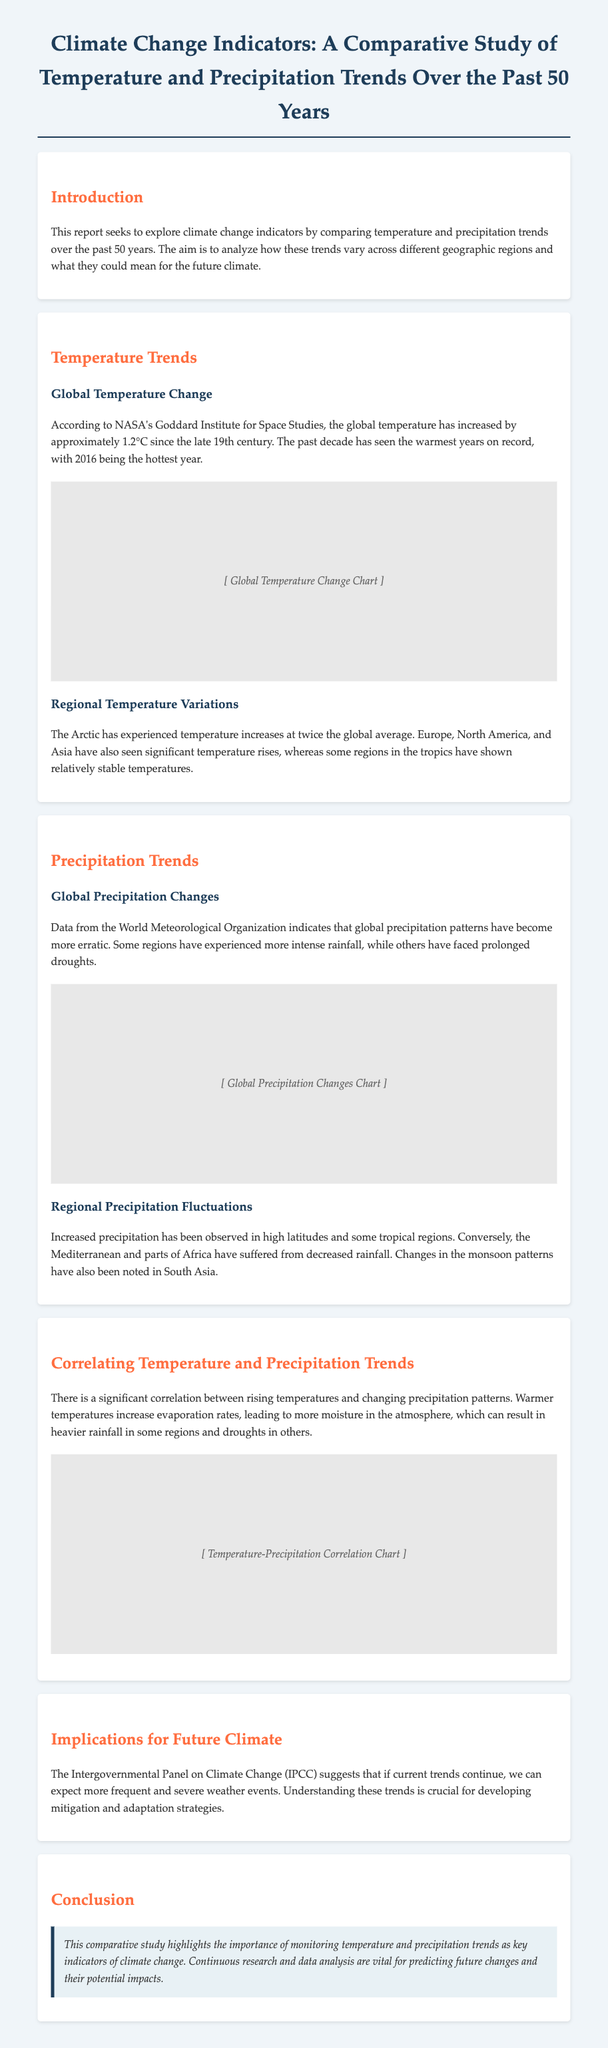What is the global temperature increase since the late 19th century? The report states that the global temperature has increased by approximately 1.2°C since the late 19th century.
Answer: 1.2°C Which year recorded the warmest temperature on record? According to the document, 2016 is noted as the hottest year on record.
Answer: 2016 What has happened to precipitation patterns globally? The document indicates that global precipitation patterns have become more erratic.
Answer: Erratic What region has experienced temperature changes at twice the global average? The report mentions that the Arctic has experienced temperature increases at twice the global average.
Answer: Arctic Which regions have seen increased rainfall? The report notes that increased precipitation has been observed in high latitudes and some tropical regions.
Answer: High latitudes and tropical regions How does warmer temperature influence precipitation? The document explains that warmer temperatures increase evaporation rates, leading to more moisture in the atmosphere.
Answer: More moisture What does the IPCC suggest about future weather events? The document indicates that the IPCC suggests if current trends continue, we can expect more frequent and severe weather events.
Answer: More frequent and severe What is the primary focus of this comparative study? The study primarily focuses on monitoring temperature and precipitation trends as key indicators of climate change.
Answer: Key indicators of climate change What type of trends does the report analyze? The report analyzes temperature and precipitation trends over the past 50 years.
Answer: Temperature and precipitation trends 